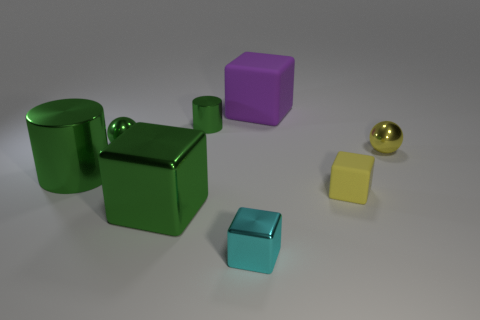What is the size of the metal block that is the same color as the small metallic cylinder?
Offer a terse response. Large. Are there any tiny green metallic balls on the left side of the cyan thing?
Provide a succinct answer. Yes. Is the number of objects that are to the right of the cyan shiny thing greater than the number of big green objects?
Provide a short and direct response. Yes. Are there any small metal objects that have the same color as the tiny rubber object?
Ensure brevity in your answer.  Yes. There is a cylinder that is the same size as the yellow matte thing; what color is it?
Make the answer very short. Green. There is a big cube that is to the left of the purple cube; are there any big cylinders behind it?
Offer a very short reply. Yes. There is a large thing that is to the right of the green cube; what is its material?
Make the answer very short. Rubber. Are the tiny block that is behind the tiny cyan metal object and the green cylinder on the left side of the small green sphere made of the same material?
Your response must be concise. No. Are there an equal number of tiny green shiny spheres that are to the right of the tiny metallic cube and objects that are on the left side of the large purple cube?
Provide a succinct answer. No. How many green spheres have the same material as the small cyan cube?
Make the answer very short. 1. 